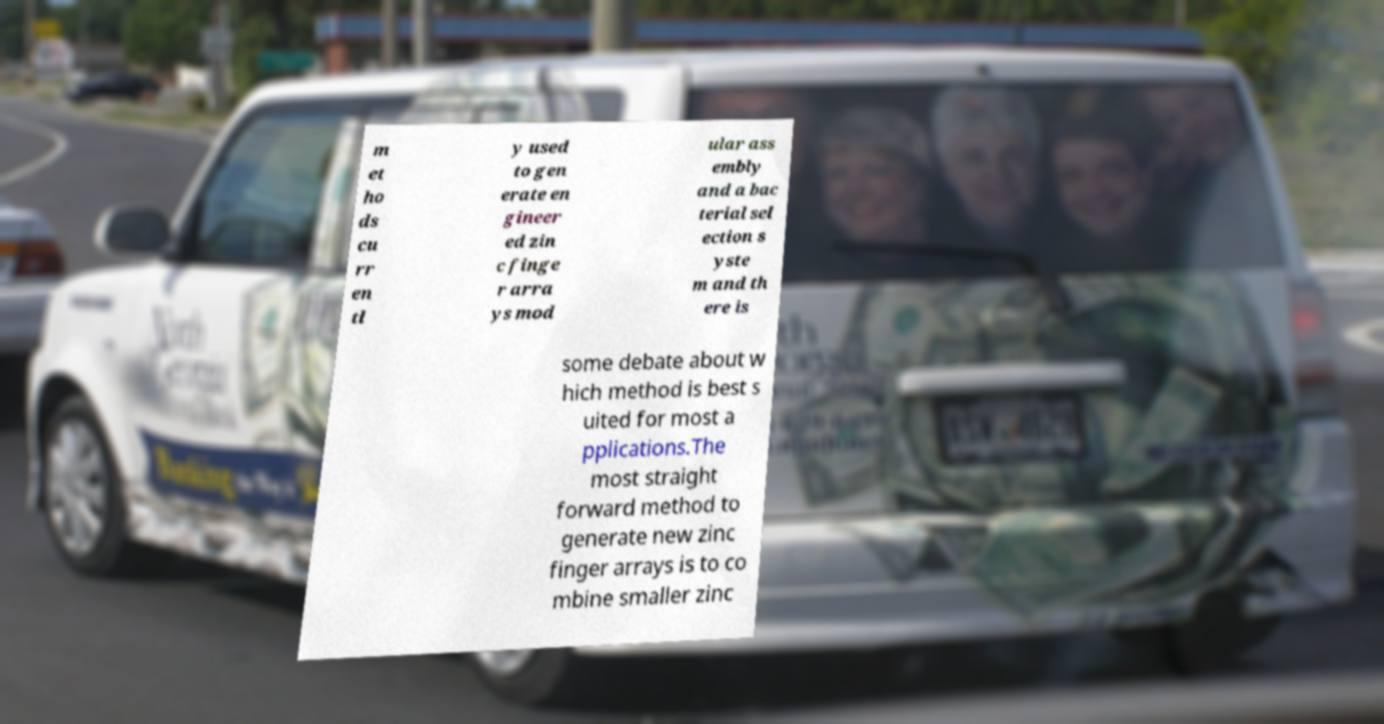There's text embedded in this image that I need extracted. Can you transcribe it verbatim? m et ho ds cu rr en tl y used to gen erate en gineer ed zin c finge r arra ys mod ular ass embly and a bac terial sel ection s yste m and th ere is some debate about w hich method is best s uited for most a pplications.The most straight forward method to generate new zinc finger arrays is to co mbine smaller zinc 